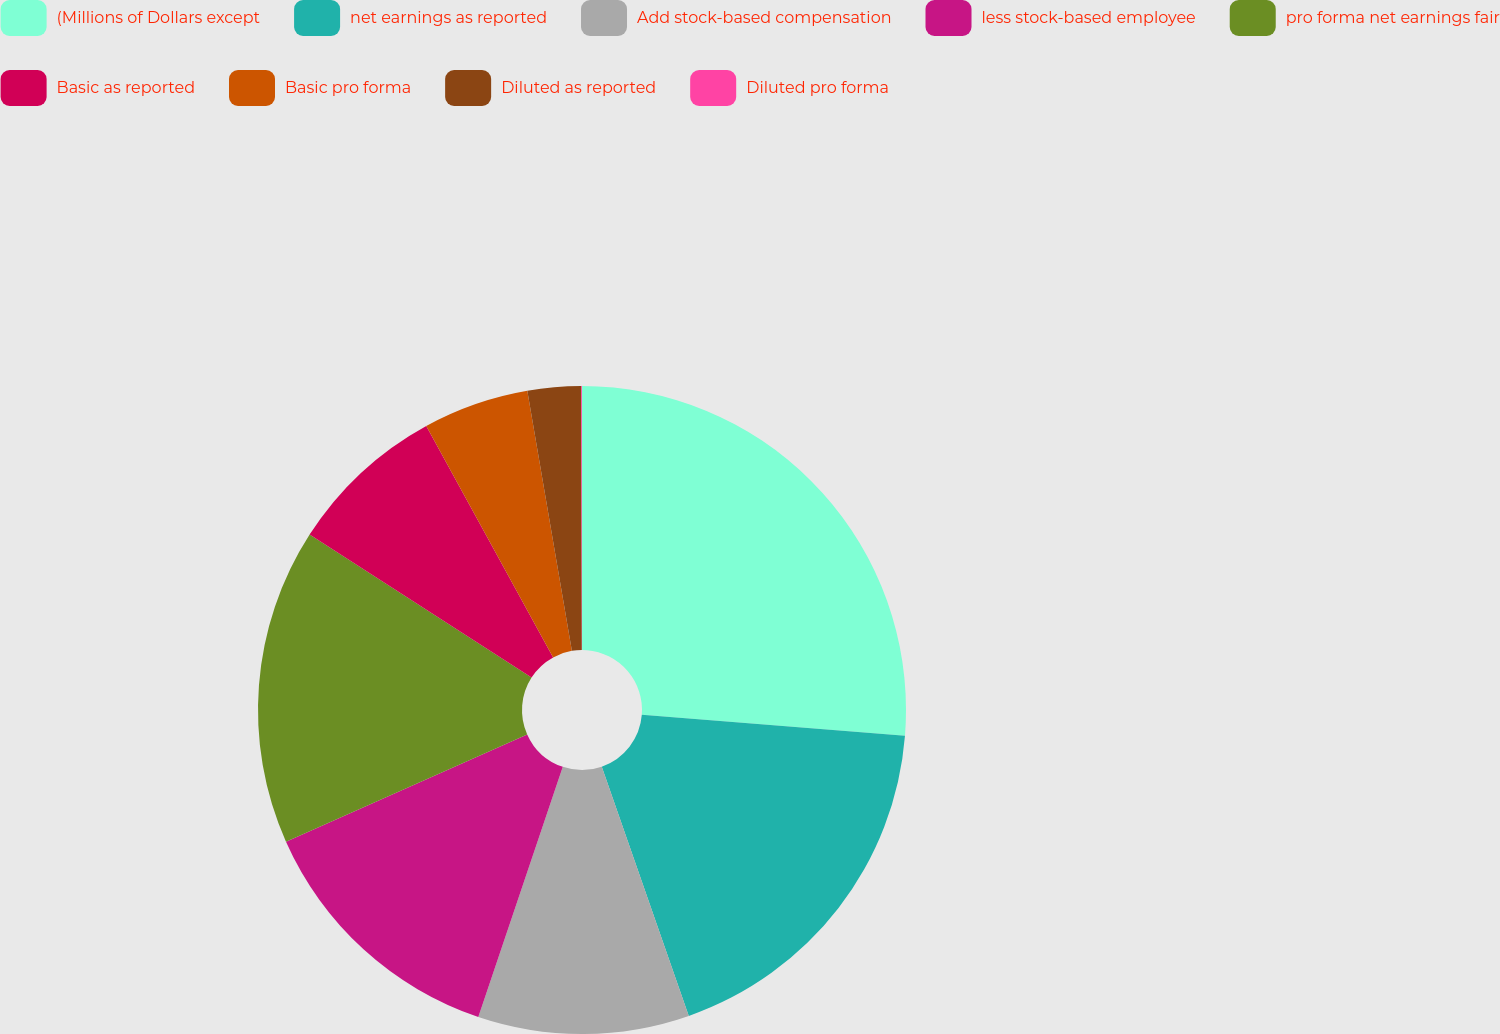Convert chart to OTSL. <chart><loc_0><loc_0><loc_500><loc_500><pie_chart><fcel>(Millions of Dollars except<fcel>net earnings as reported<fcel>Add stock-based compensation<fcel>less stock-based employee<fcel>pro forma net earnings fair<fcel>Basic as reported<fcel>Basic pro forma<fcel>Diluted as reported<fcel>Diluted pro forma<nl><fcel>26.26%<fcel>18.39%<fcel>10.53%<fcel>13.15%<fcel>15.77%<fcel>7.91%<fcel>5.28%<fcel>2.66%<fcel>0.04%<nl></chart> 